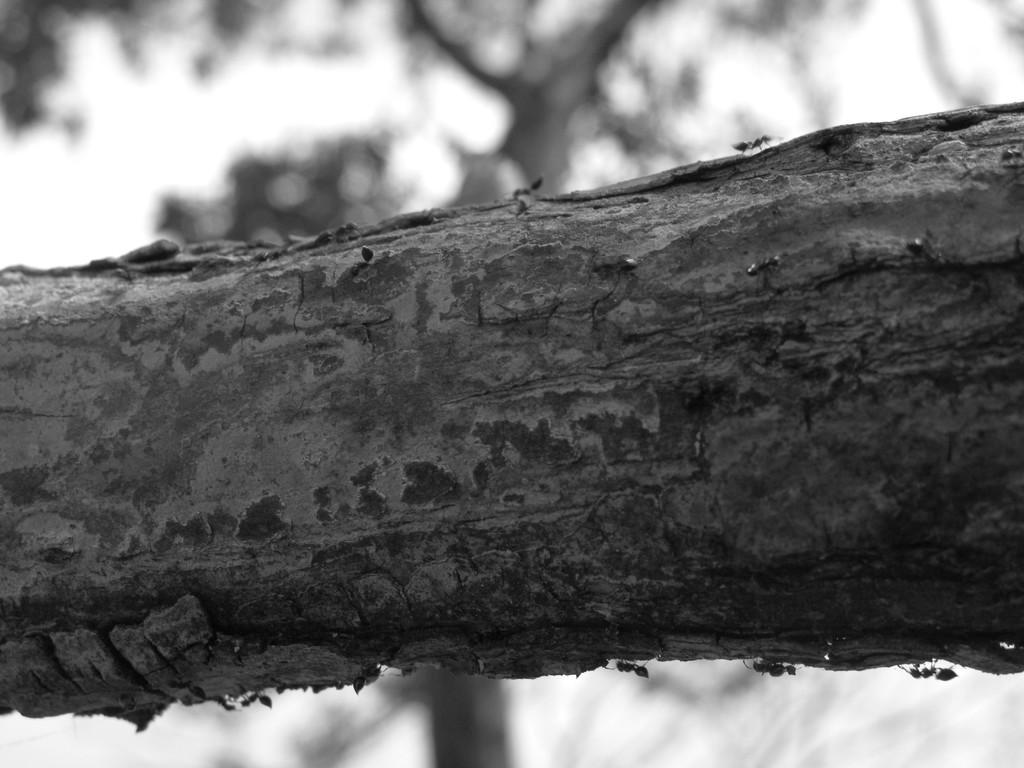Can you describe this image briefly? This is a black and white image. Here I can see a trunk. The background is blurred. 